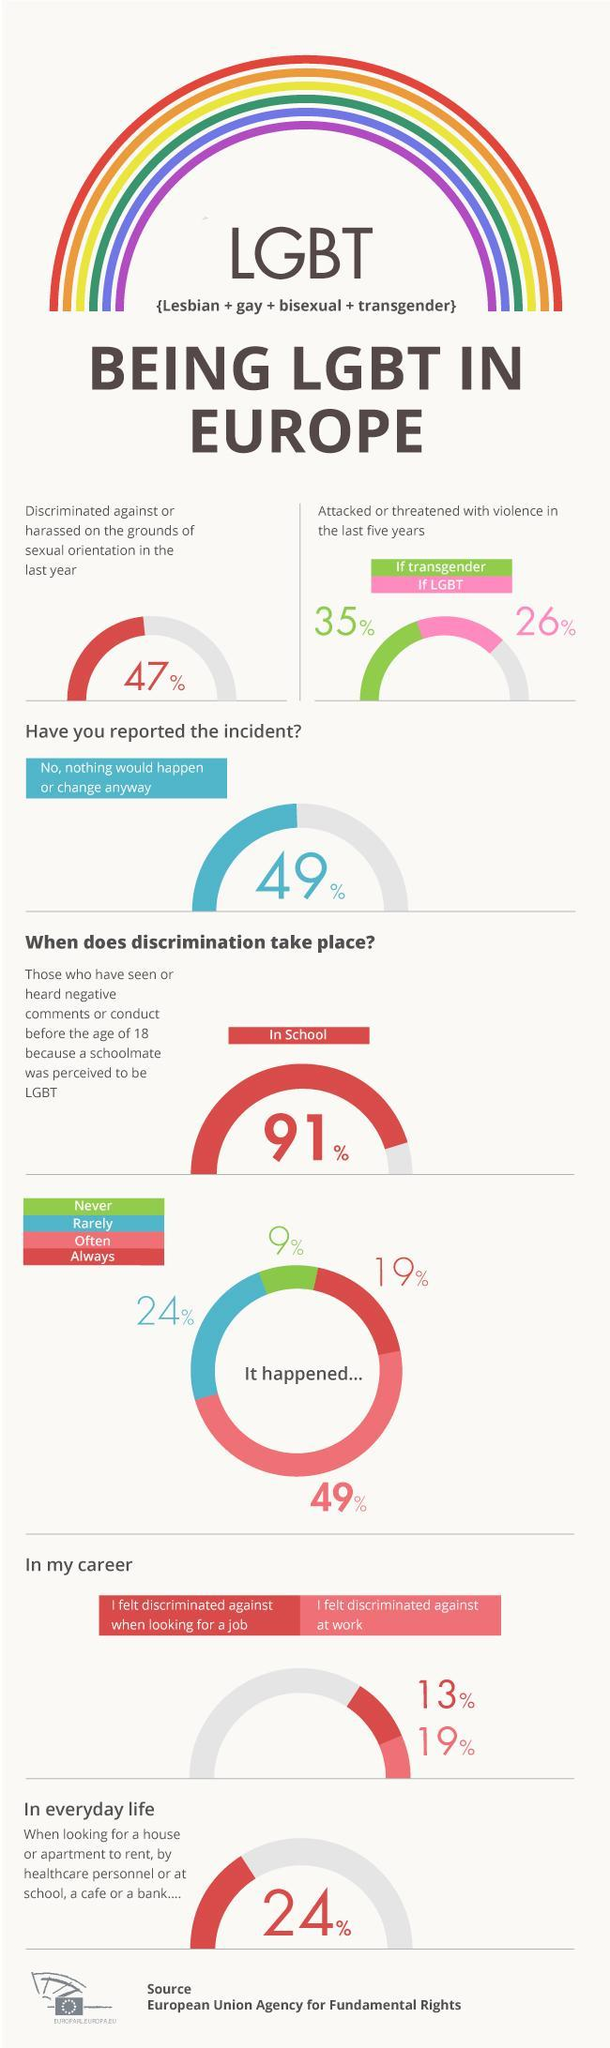Point out several critical features in this image. According to recent statistics, 26% of LGBT people in Europe have been attacked or threatened with violence in the past five years. According to recent statistics, 35% of transgender individuals in Europe have been the victim of violence or aggression in the past five years. According to a recent study, 47% of LGBT individuals in Europe experienced discrimination based on their sexual orientation in the past year. According to a survey of LGBT individuals in Europe, 19% reported feeling discriminated against at work. 